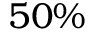<formula> <loc_0><loc_0><loc_500><loc_500>5 0 \%</formula> 